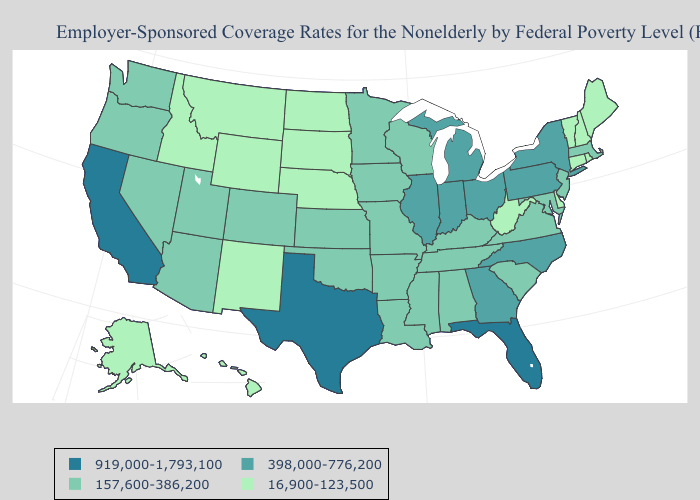Is the legend a continuous bar?
Short answer required. No. Name the states that have a value in the range 919,000-1,793,100?
Short answer required. California, Florida, Texas. Among the states that border Missouri , does Nebraska have the lowest value?
Concise answer only. Yes. What is the lowest value in the South?
Answer briefly. 16,900-123,500. Among the states that border South Dakota , which have the lowest value?
Answer briefly. Montana, Nebraska, North Dakota, Wyoming. What is the value of New York?
Answer briefly. 398,000-776,200. Does the first symbol in the legend represent the smallest category?
Keep it brief. No. Does Maine have the lowest value in the Northeast?
Keep it brief. Yes. Among the states that border Michigan , which have the highest value?
Answer briefly. Indiana, Ohio. Does Illinois have the same value as New Jersey?
Answer briefly. No. Among the states that border North Dakota , does Minnesota have the highest value?
Quick response, please. Yes. What is the value of Texas?
Keep it brief. 919,000-1,793,100. Name the states that have a value in the range 16,900-123,500?
Keep it brief. Alaska, Connecticut, Delaware, Hawaii, Idaho, Maine, Montana, Nebraska, New Hampshire, New Mexico, North Dakota, Rhode Island, South Dakota, Vermont, West Virginia, Wyoming. Is the legend a continuous bar?
Write a very short answer. No. 